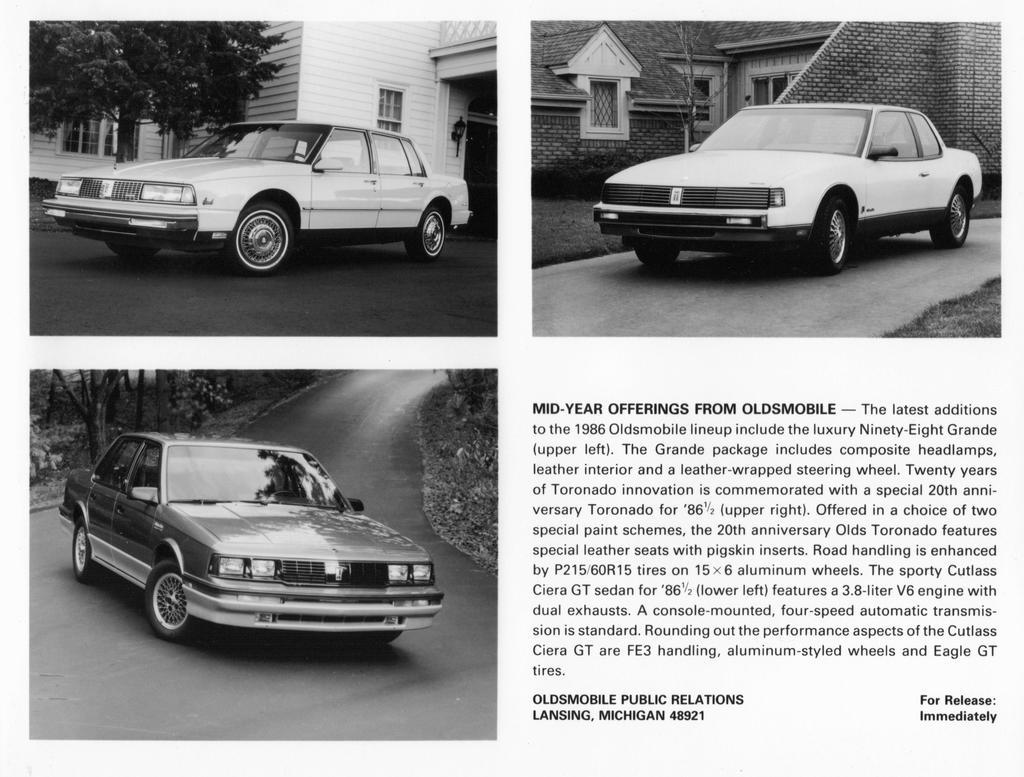What type of vehicles can be seen on the road in the image? There are cars on the road in the image. What can be seen in the background of the image? There are trees and buildings visible in the background of the image. What type of design can be seen on the cushion in the image? There is no cushion present in the image. What unit of measurement is used to determine the height of the buildings in the image? The facts provided do not specify the unit of measurement used for the buildings in the image. 